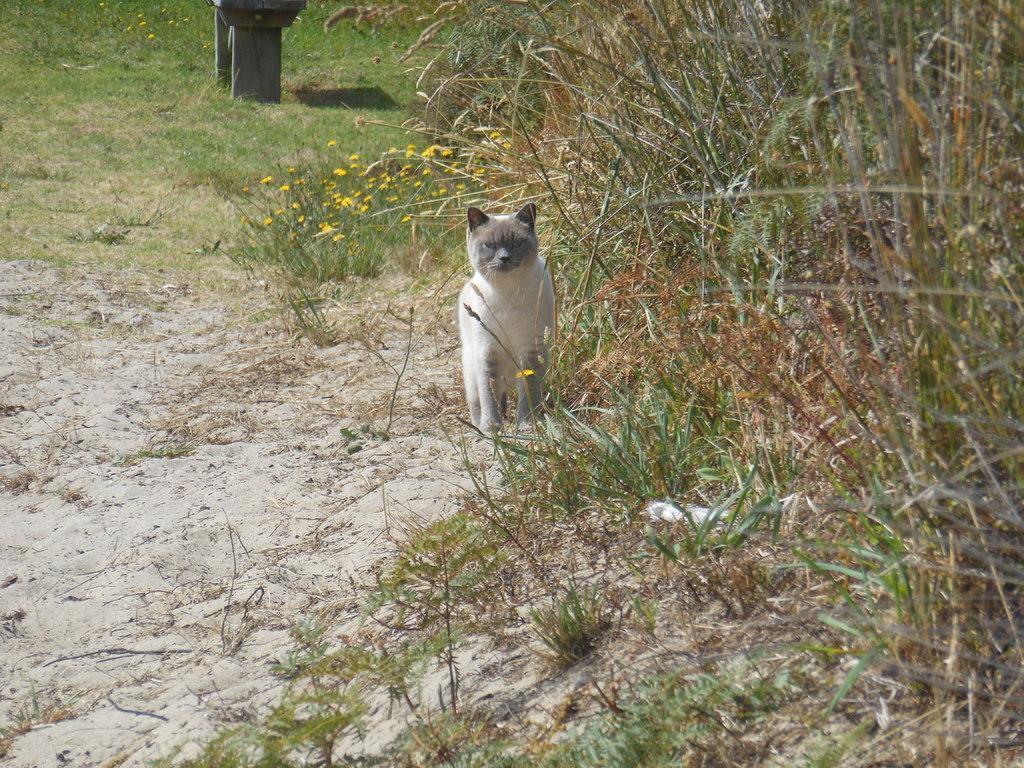In one or two sentences, can you explain what this image depicts? In this image I can see an animal which is in white and brown color. Background I can see few flowers in yellow color and I can see the grass in brown and green color. 